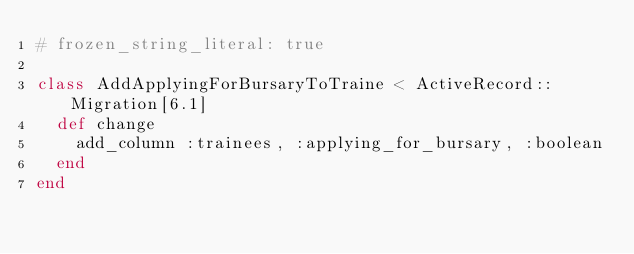<code> <loc_0><loc_0><loc_500><loc_500><_Ruby_># frozen_string_literal: true

class AddApplyingForBursaryToTraine < ActiveRecord::Migration[6.1]
  def change
    add_column :trainees, :applying_for_bursary, :boolean
  end
end
</code> 